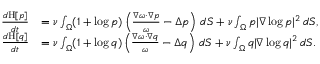Convert formula to latex. <formula><loc_0><loc_0><loc_500><loc_500>\begin{array} { r l } { \frac { d H [ p ] } { d t } } & { = \nu \int _ { \Omega } ( 1 + \log p ) \left ( \frac { \nabla \omega \cdot \nabla p } { \omega } - \Delta p \right ) \, d S + \nu \int _ { \Omega } p | \nabla \log p | ^ { 2 } \, d S , } \\ { \frac { d H [ q ] } { d t } } & { = \nu \int _ { \Omega } ( 1 + \log q ) \left ( \frac { \nabla \omega \cdot \nabla q } { \omega } - \Delta q \right ) \, d S + \nu \int _ { \Omega } q | \nabla \log q | ^ { 2 } \, d S . } \end{array}</formula> 